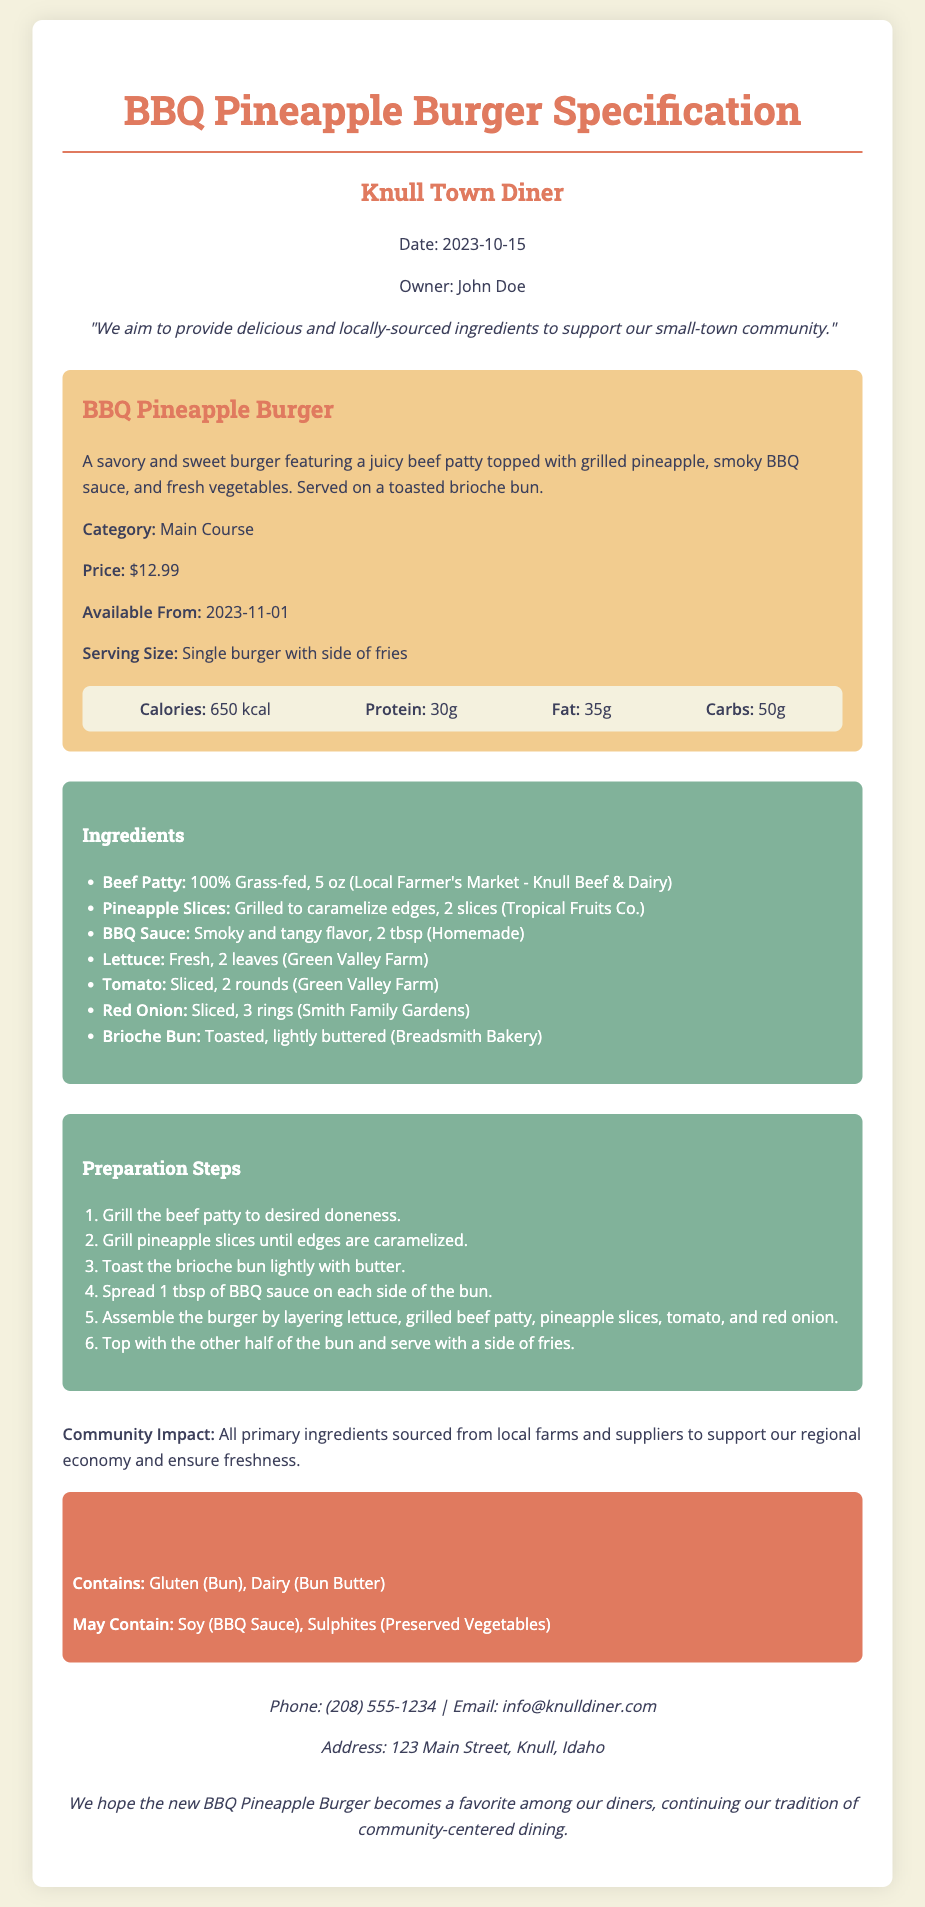what is the name of the new menu item? The new menu item is titled in the document as "BBQ Pineapple Burger".
Answer: BBQ Pineapple Burger who is the owner of Knull Town Diner? The owner's name is mentioned in the document as "John Doe".
Answer: John Doe what is the price of the BBQ Pineapple Burger? The price is explicitly stated as "$12.99".
Answer: $12.99 when will the BBQ Pineapple Burger be available? The document specifies the availability date as "2023-11-01".
Answer: 2023-11-01 how many calories are in the BBQ Pineapple Burger? The nutritional information provides the calorie count as "650 kcal".
Answer: 650 kcal which farm provides the beef patty? The document notes that the beef patty is sourced from "Local Farmer's Market - Knull Beef & Dairy".
Answer: Local Farmer's Market - Knull Beef & Dairy what type of sauce is used in the BBQ Pineapple Burger? The documentation describes the sauce as "Smoky and tangy flavor".
Answer: Smoky and tangy flavor how is the pineapple prepared for the burger? The preparation method indicated states it is "Grilled to caramelize edges".
Answer: Grilled to caramelize edges what primary community benefit is highlighted in the document? The document emphasizes supporting the "regional economy" through sourcing local ingredients.
Answer: regional economy 